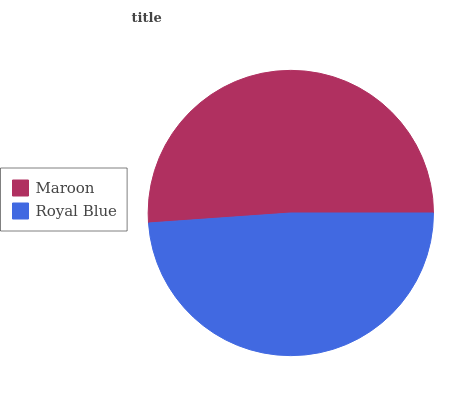Is Royal Blue the minimum?
Answer yes or no. Yes. Is Maroon the maximum?
Answer yes or no. Yes. Is Royal Blue the maximum?
Answer yes or no. No. Is Maroon greater than Royal Blue?
Answer yes or no. Yes. Is Royal Blue less than Maroon?
Answer yes or no. Yes. Is Royal Blue greater than Maroon?
Answer yes or no. No. Is Maroon less than Royal Blue?
Answer yes or no. No. Is Maroon the high median?
Answer yes or no. Yes. Is Royal Blue the low median?
Answer yes or no. Yes. Is Royal Blue the high median?
Answer yes or no. No. Is Maroon the low median?
Answer yes or no. No. 